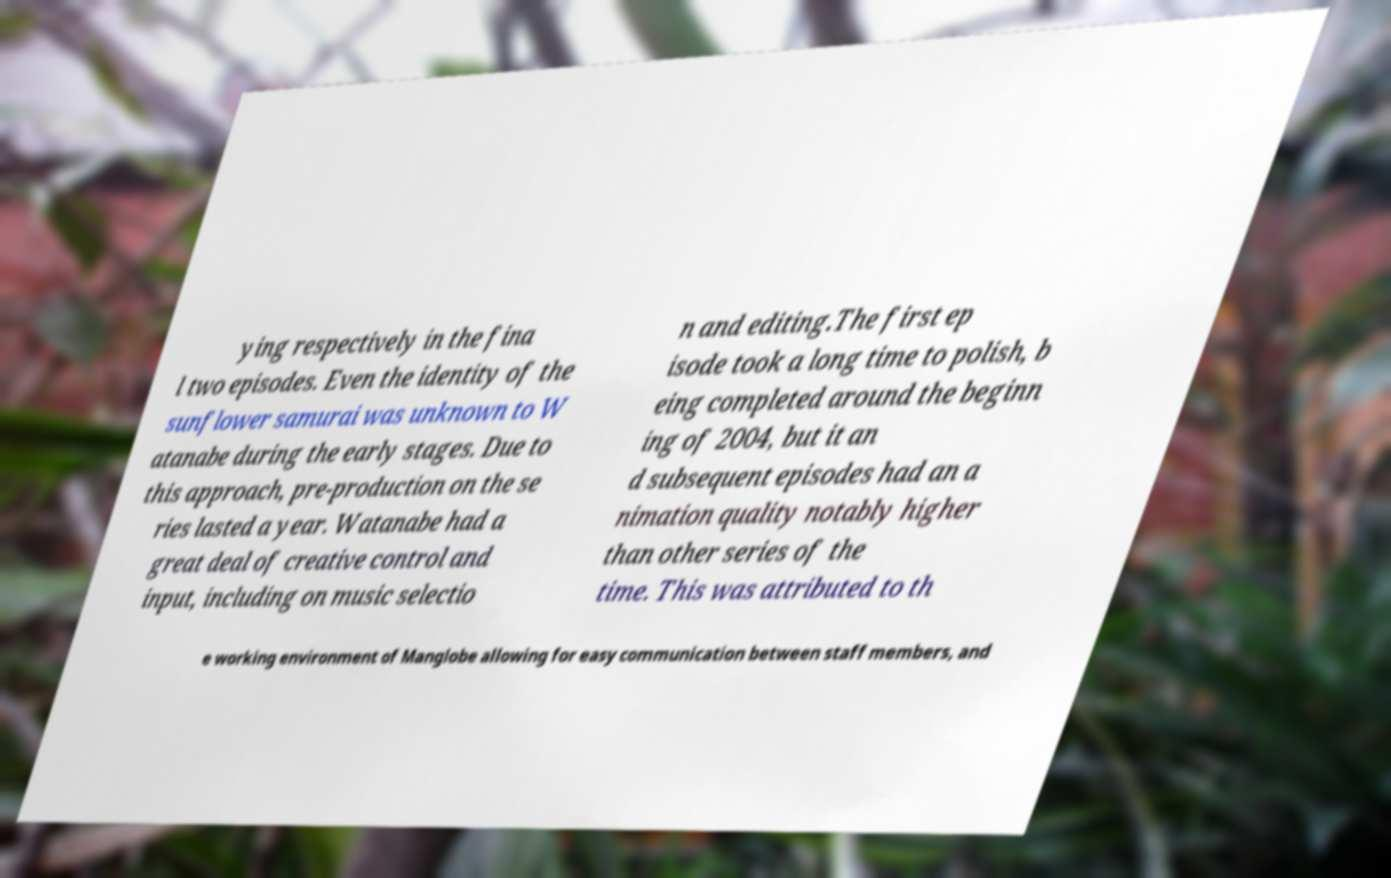Could you assist in decoding the text presented in this image and type it out clearly? ying respectively in the fina l two episodes. Even the identity of the sunflower samurai was unknown to W atanabe during the early stages. Due to this approach, pre-production on the se ries lasted a year. Watanabe had a great deal of creative control and input, including on music selectio n and editing.The first ep isode took a long time to polish, b eing completed around the beginn ing of 2004, but it an d subsequent episodes had an a nimation quality notably higher than other series of the time. This was attributed to th e working environment of Manglobe allowing for easy communication between staff members, and 